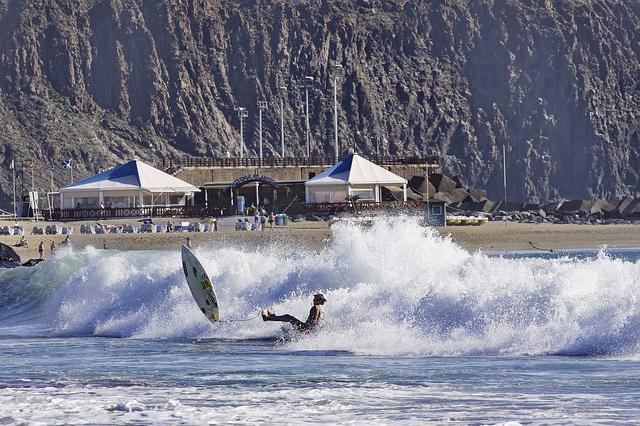What sort of structures are similar in the background?
Give a very brief answer. Tents. Did the person fall off his surfboard?
Give a very brief answer. Yes. What is this person doing?
Keep it brief. Surfing. 